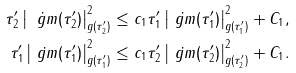<formula> <loc_0><loc_0><loc_500><loc_500>\tau _ { 2 } ^ { \prime } \left | \dot { \ g m } ( \tau _ { 2 } ^ { \prime } ) \right | _ { g ( \tau _ { 2 } ^ { \prime } ) } ^ { 2 } & \leq c _ { 1 } \tau _ { 1 } ^ { \prime } \left | \dot { \ g m } ( \tau _ { 1 } ^ { \prime } ) \right | _ { g ( \tau _ { 1 } ^ { \prime } ) } ^ { 2 } + C _ { 1 } , \\ \tau _ { 1 } ^ { \prime } \left | \dot { \ g m } ( \tau _ { 1 } ^ { \prime } ) \right | _ { g ( \tau _ { 1 } ^ { \prime } ) } ^ { 2 } & \leq c _ { 1 } \tau _ { 2 } ^ { \prime } \left | \dot { \ g m } ( \tau _ { 2 } ^ { \prime } ) \right | _ { g ( \tau _ { 2 } ^ { \prime } ) } ^ { 2 } + C _ { 1 } .</formula> 